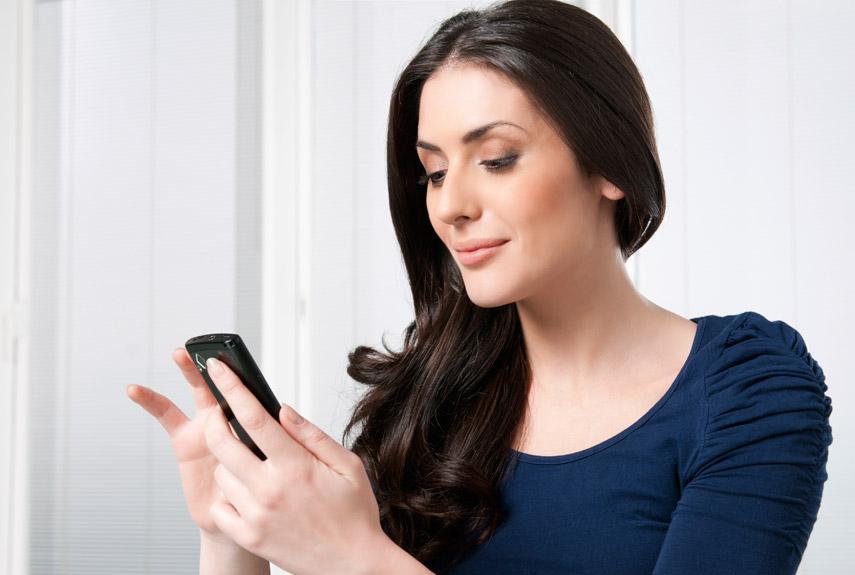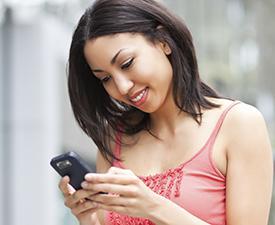The first image is the image on the left, the second image is the image on the right. For the images displayed, is the sentence "There are two brown haired women holding their phones." factually correct? Answer yes or no. Yes. The first image is the image on the left, the second image is the image on the right. Analyze the images presented: Is the assertion "Each of the images shows a female holding and looking at a cell phone." valid? Answer yes or no. Yes. 